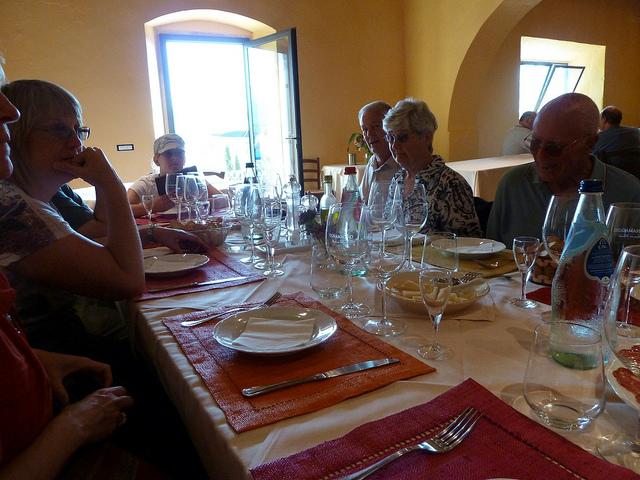How many pitchers are visible?
Give a very brief answer. 3. Is this someone's home?
Quick response, please. No. How many plates are on this table?
Concise answer only. 6. What pattern is the tablecloth?
Keep it brief. Solid. Have these people already eaten?
Keep it brief. No. 